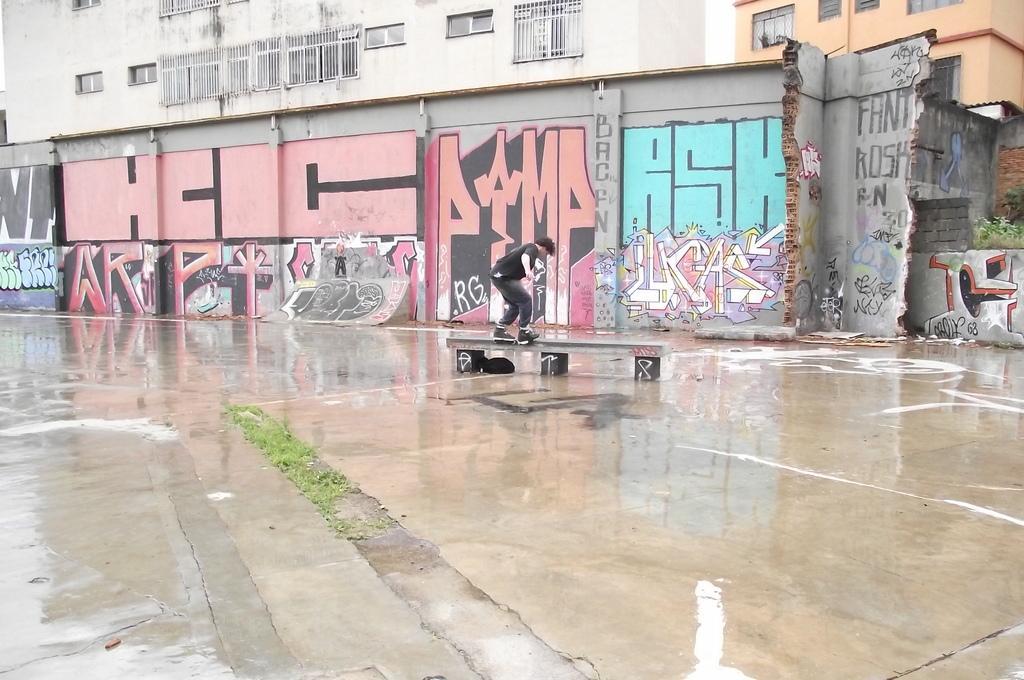How would you summarize this image in a sentence or two? In this image there is a person skating on the floor and there is a bench. In the background there is a building and on the wall of the building there is a painting. On the right side of the image we can see there are some plants. 